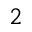<formula> <loc_0><loc_0><loc_500><loc_500>2</formula> 